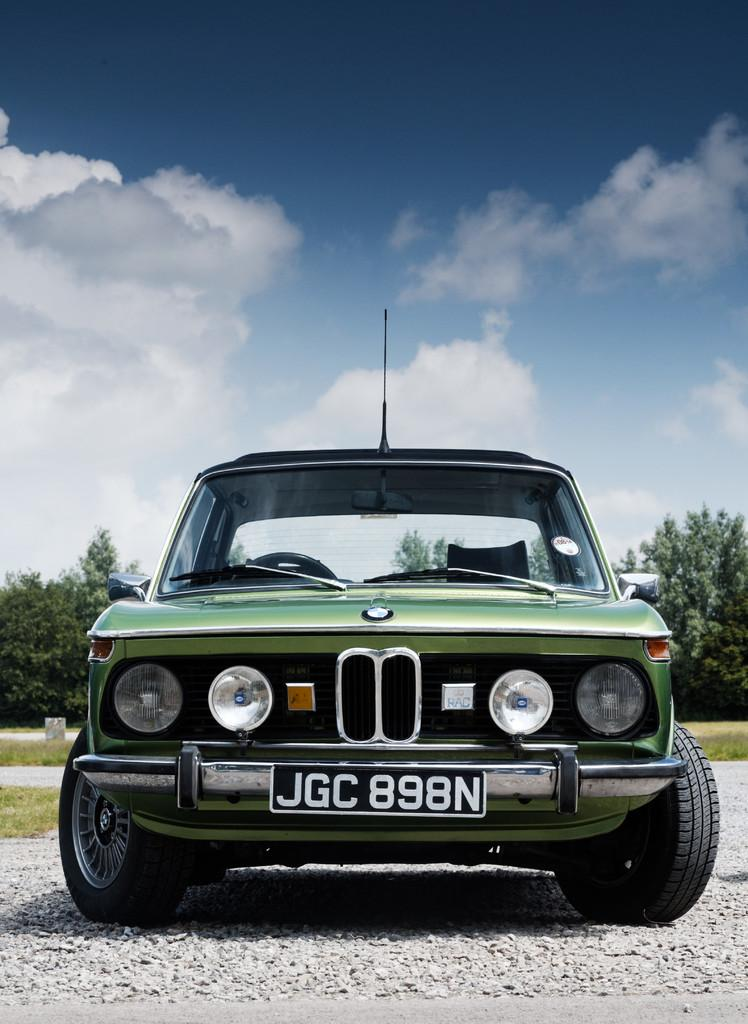What is the main subject of the image? There is a vehicle in the image. Can you describe the color of the vehicle? The vehicle is green. What can be seen in the background of the image? There are trees in the background of the image. What is the color of the trees? The trees are green. How would you describe the sky in the image? The sky is blue and white. Where is the hydrant located in the image? There is no hydrant present in the image. What type of trousers is the vehicle wearing in the image? Vehicles do not wear trousers, as they are inanimate objects. 